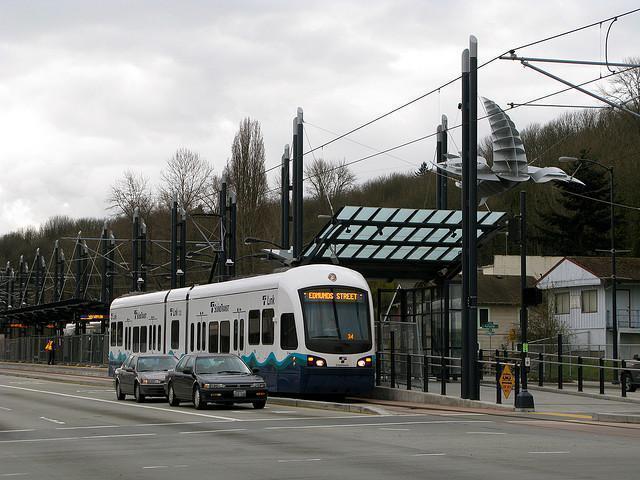What are white lines on road called?
Select the accurate answer and provide justification: `Answer: choice
Rationale: srationale.`
Options: Edge mark, border line, traffic line, cutting line. Answer: border line.
Rationale: The lines are used to mark the line on the roads. 